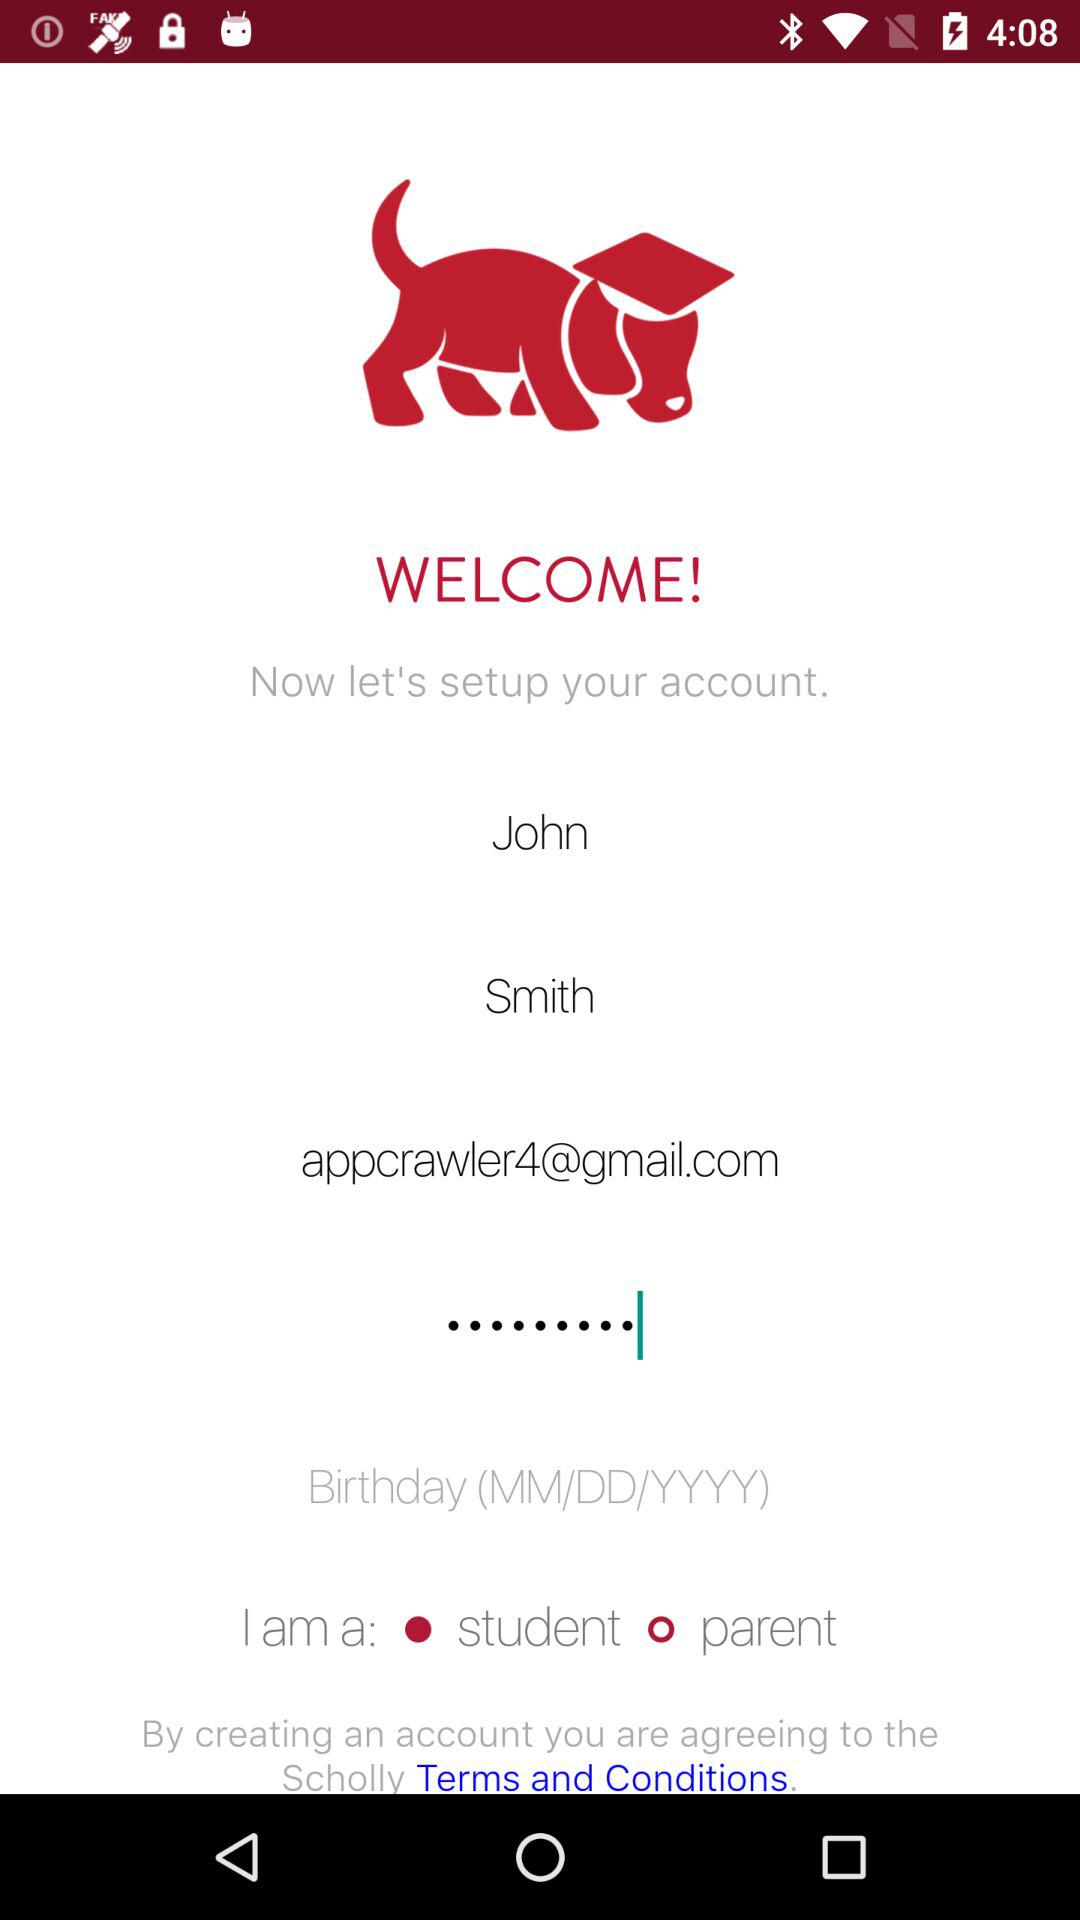What is the name of the user? The user name is John Smith. 